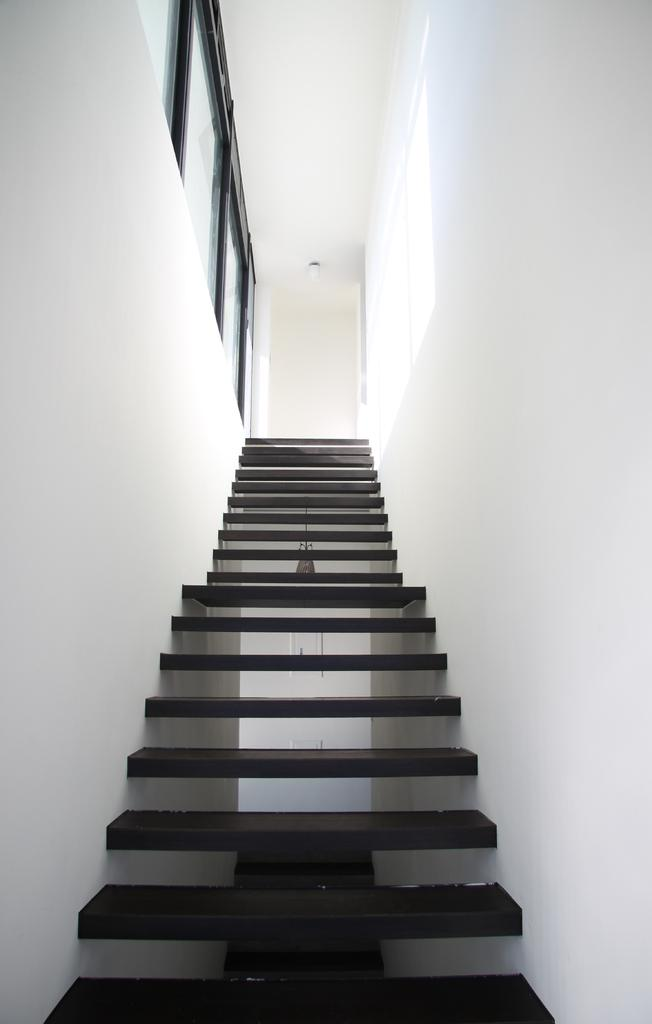What is the main feature in the center of the image? There are stairs in the center of the image. What is attached to the stairs? There is a wall with a hanging through the stairs. What can be seen at the top of the image? There is a wall visible at the top of the image. How many eggs are visible on the boat in the image? There is no boat or eggs present in the image. What type of brick is used to construct the wall in the image? There is no information about the type of brick used to construct the wall in the image. 